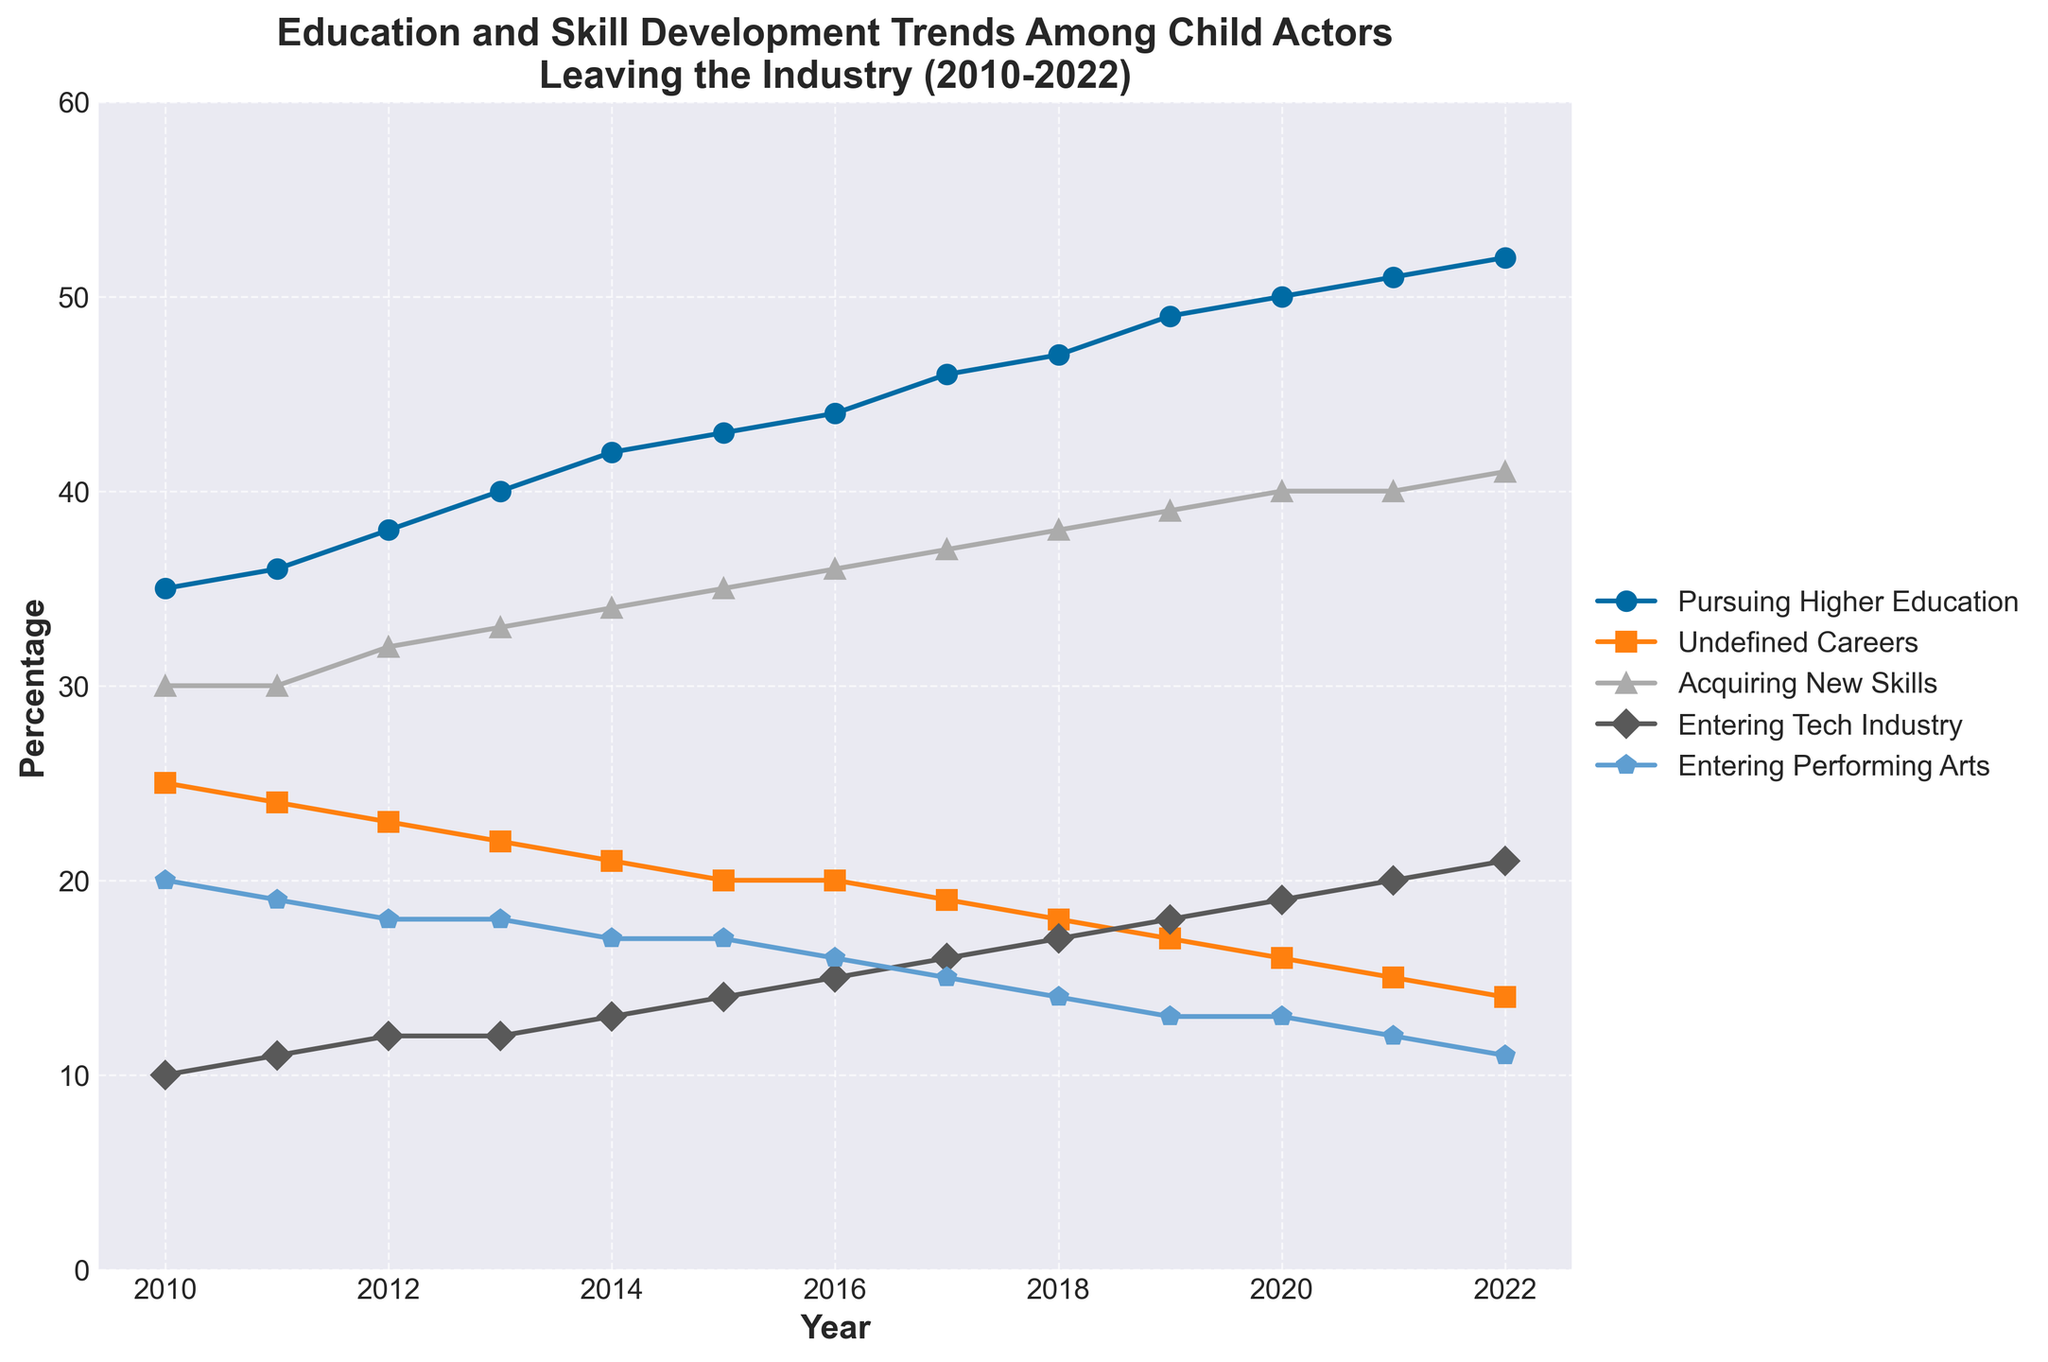What is the title of the plot? The title is located at the top of the plot and provides a description of the data being visualized.
Answer: Education and Skill Development Trends Among Child Actors Leaving the Industry (2010-2022) What percentage of child actors pursued higher education in 2016? To find this, look at the data corresponding to the year 2016 on the line labeled "Pursuing Higher Education".
Answer: 44% Which category has the highest percentage in 2014? Scan the line plot and identify which category reaches the highest point above the year 2014.
Answer: Percentage_Pursuing_Higher_Education How did the percentage of child actors entering the tech industry change from 2011 to 2021? Find the data points for "Entering Tech Industry" in the years 2011 and 2021, then calculate the difference. In 2011, it's 11%, and in 2021, it's 20%.
Answer: Increased by 9% Which category showed a continuous increasing trend throughout the entire period from 2010 to 2022? Look for a line that perpetually rises without dropping, from the start year to the end year.
Answer: Percentage_Pursuing_Higher_Education What is the percentage difference between child actors acquiring new skills and those entering performing arts in 2020? Identify the percentages for both categories in 2020, which are 40% for acquiring new skills and 13% for entering performing arts, then subtract the smaller value from the larger value.
Answer: 27% On average, what percentage of child actors had undefined careers over the period from 2010 to 2022? Add the percentages of child actors with undefined careers for each year, then divide by the number of years (13 years). Average = (25+24+23+22+21+20+20+19+18+17+16+15+14)/13 = 19.
Answer: 19% Which year saw the highest percentage of child actors entering the tech industry? Find the peak value on the line labeled "Entering Tech Industry".
Answer: 2022 Is the trend for child actors entering the performing arts industry increasing or decreasing from 2010 to 2022? Examine the line labeled "Entering Performing Arts" and see whether it generally slopes upwards or downwards.
Answer: Decreasing What is the rate of increase in the percentage of child actors acquiring new skills from 2010 to 2020? Calculate the percentage difference between 2010 and 2020, then divide by the number of years (2020-2010 = 10 years). The increase is from 30% to 40%, so (40-30)/10 = 1% per year.
Answer: 1% per year 